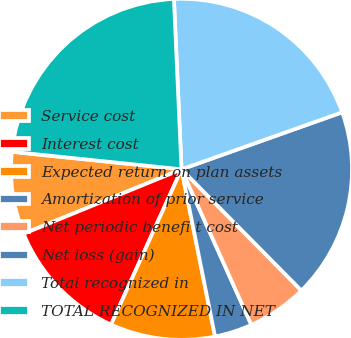<chart> <loc_0><loc_0><loc_500><loc_500><pie_chart><fcel>Service cost<fcel>Interest cost<fcel>Expected return on plan assets<fcel>Amortization of prior service<fcel>Net periodic benefi t cost<fcel>Net loss (gain)<fcel>Total recognized in<fcel>TOTAL RECOGNIZED IN NET<nl><fcel>7.81%<fcel>12.05%<fcel>9.93%<fcel>3.57%<fcel>5.69%<fcel>18.02%<fcel>20.28%<fcel>22.65%<nl></chart> 